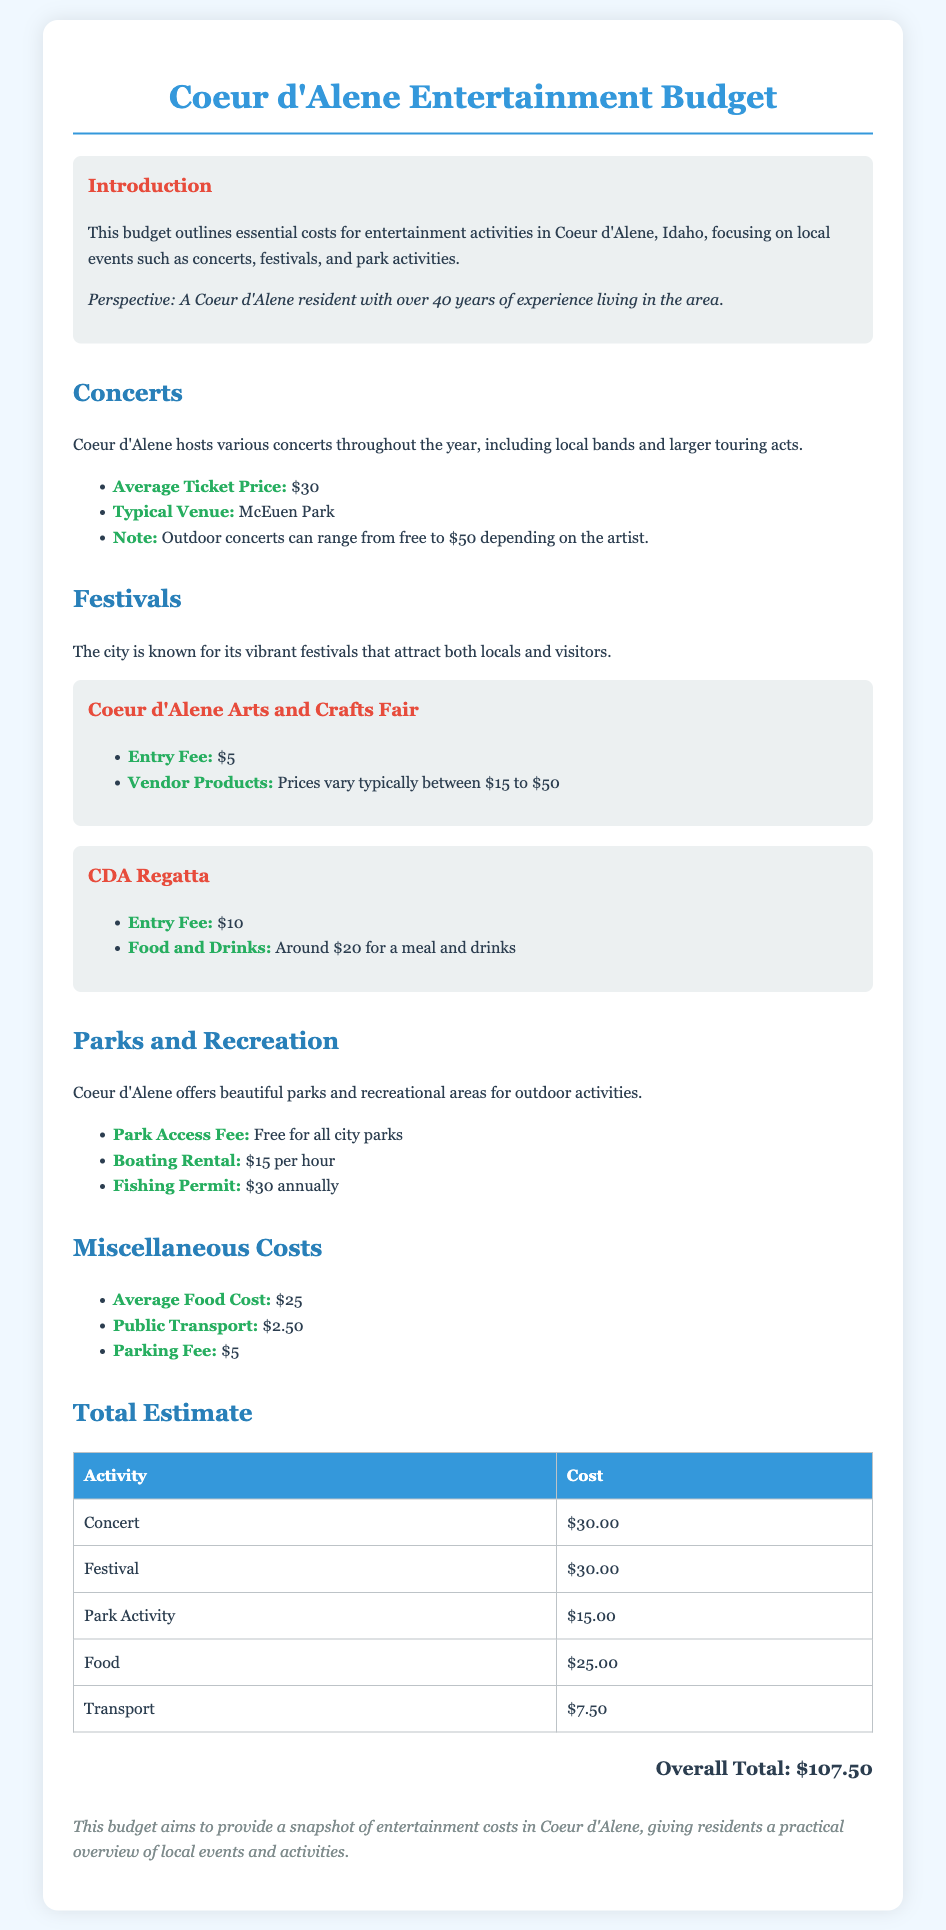what is the average ticket price for concerts? The document states that the average ticket price for concerts is $30.
Answer: $30 what is the entry fee for the Coeur d'Alene Arts and Crafts Fair? The entry fee for the Coeur d'Alene Arts and Crafts Fair is listed as $5.
Answer: $5 how much does a fishing permit cost annually? The document mentions that a fishing permit costs $30 annually.
Answer: $30 what is the cost of food on average? The average food cost mentioned in the document is $25.
Answer: $25 how much can one expect to spend on food and drinks at the CDA Regatta? The document indicates that food and drinks at the CDA Regatta cost around $20.
Answer: $20 what is the park access fee? According to the document, park access is free for all city parks.
Answer: Free what is the total estimated cost for attending a concert, festival, park activity, food, and transport? The total estimated cost is the sum of all these activities, which amounts to $107.50.
Answer: $107.50 is there a parking fee mentioned in the document? Yes, the document lists a parking fee of $5.
Answer: $5 how much does it cost per hour to rent a boat? The document states that boating rental costs $15 per hour.
Answer: $15 